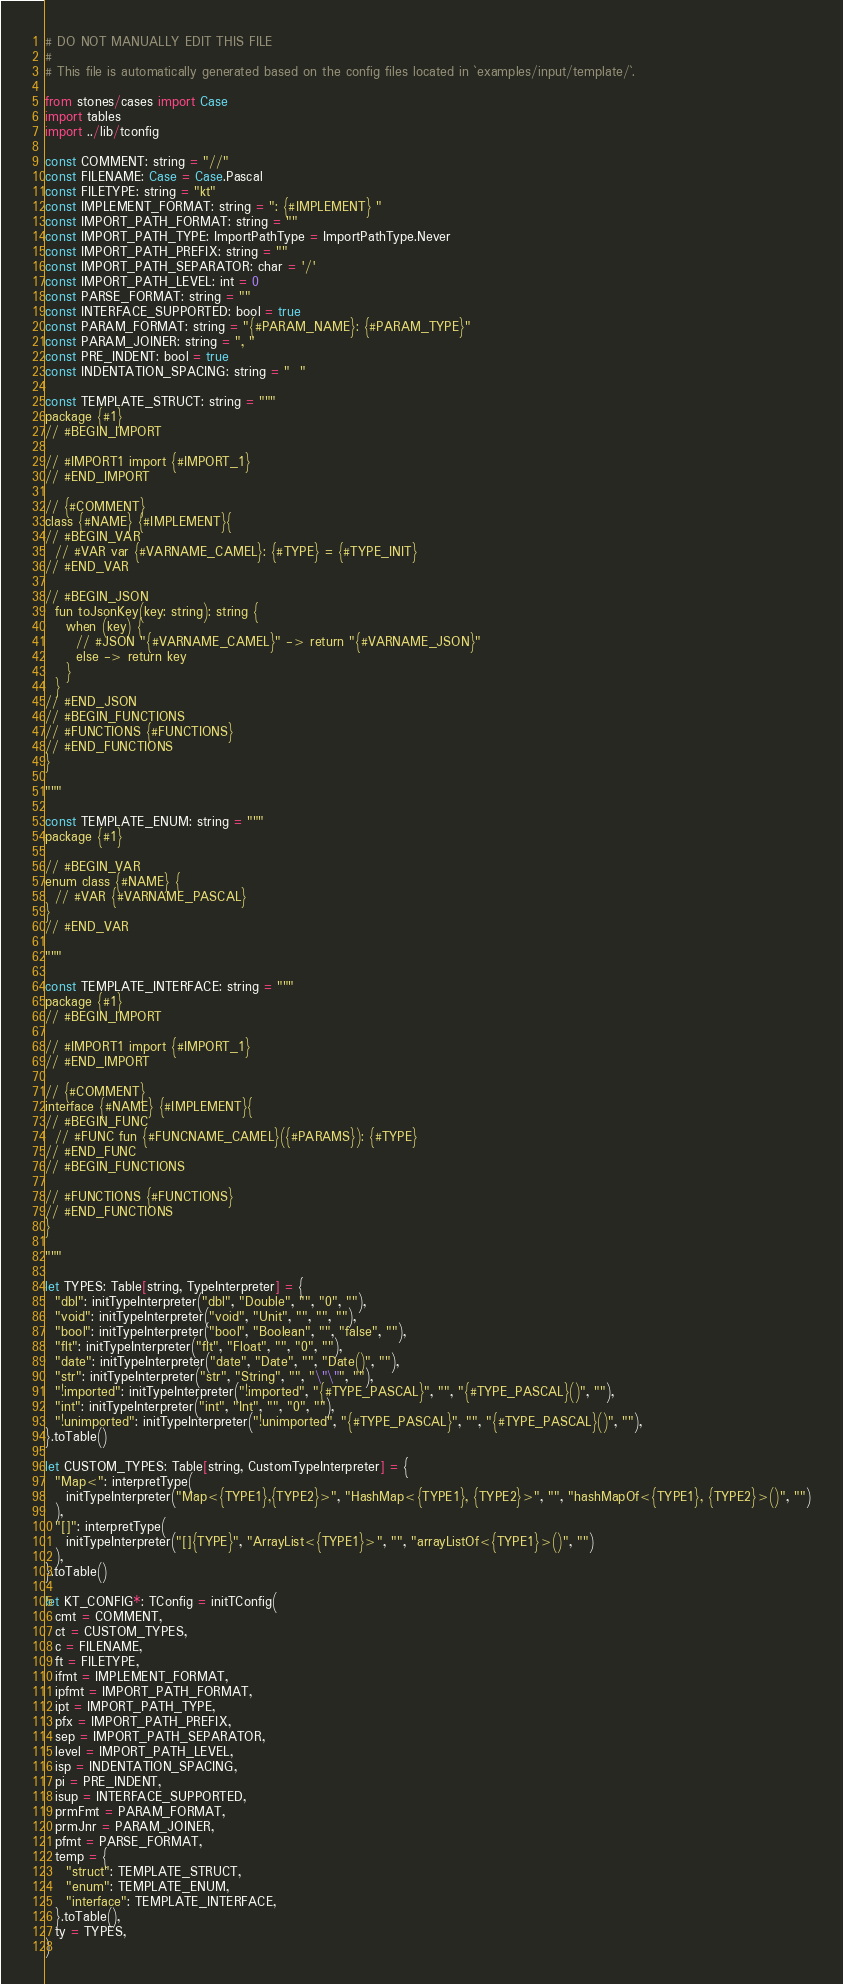<code> <loc_0><loc_0><loc_500><loc_500><_Nim_># DO NOT MANUALLY EDIT THIS FILE
#
# This file is automatically generated based on the config files located in `examples/input/template/`.

from stones/cases import Case
import tables
import ../lib/tconfig

const COMMENT: string = "//"
const FILENAME: Case = Case.Pascal
const FILETYPE: string = "kt"
const IMPLEMENT_FORMAT: string = ": {#IMPLEMENT} "
const IMPORT_PATH_FORMAT: string = ""
const IMPORT_PATH_TYPE: ImportPathType = ImportPathType.Never
const IMPORT_PATH_PREFIX: string = ""
const IMPORT_PATH_SEPARATOR: char = '/'
const IMPORT_PATH_LEVEL: int = 0
const PARSE_FORMAT: string = ""
const INTERFACE_SUPPORTED: bool = true
const PARAM_FORMAT: string = "{#PARAM_NAME}: {#PARAM_TYPE}"
const PARAM_JOINER: string = ", "
const PRE_INDENT: bool = true
const INDENTATION_SPACING: string = "  "

const TEMPLATE_STRUCT: string = """
package {#1}
// #BEGIN_IMPORT

// #IMPORT1 import {#IMPORT_1}
// #END_IMPORT

// {#COMMENT}
class {#NAME} {#IMPLEMENT}{
// #BEGIN_VAR
  // #VAR var {#VARNAME_CAMEL}: {#TYPE} = {#TYPE_INIT}
// #END_VAR

// #BEGIN_JSON
  fun toJsonKey(key: string): string {
    when (key) {
      // #JSON "{#VARNAME_CAMEL}" -> return "{#VARNAME_JSON}"
      else -> return key
    }
  }
// #END_JSON
// #BEGIN_FUNCTIONS
// #FUNCTIONS {#FUNCTIONS}
// #END_FUNCTIONS
}

"""

const TEMPLATE_ENUM: string = """
package {#1}

// #BEGIN_VAR
enum class {#NAME} {
  // #VAR {#VARNAME_PASCAL}
}
// #END_VAR

"""

const TEMPLATE_INTERFACE: string = """
package {#1}
// #BEGIN_IMPORT

// #IMPORT1 import {#IMPORT_1}
// #END_IMPORT

// {#COMMENT}
interface {#NAME} {#IMPLEMENT}{
// #BEGIN_FUNC
  // #FUNC fun {#FUNCNAME_CAMEL}({#PARAMS}): {#TYPE}
// #END_FUNC
// #BEGIN_FUNCTIONS

// #FUNCTIONS {#FUNCTIONS}
// #END_FUNCTIONS
}

"""

let TYPES: Table[string, TypeInterpreter] = {
  "dbl": initTypeInterpreter("dbl", "Double", "", "0", ""),
  "void": initTypeInterpreter("void", "Unit", "", "", ""),
  "bool": initTypeInterpreter("bool", "Boolean", "", "false", ""),
  "flt": initTypeInterpreter("flt", "Float", "", "0", ""),
  "date": initTypeInterpreter("date", "Date", "", "Date()", ""),
  "str": initTypeInterpreter("str", "String", "", "\"\"", ""),
  "!imported": initTypeInterpreter("!imported", "{#TYPE_PASCAL}", "", "{#TYPE_PASCAL}()", ""),
  "int": initTypeInterpreter("int", "Int", "", "0", ""),
  "!unimported": initTypeInterpreter("!unimported", "{#TYPE_PASCAL}", "", "{#TYPE_PASCAL}()", ""),
}.toTable()

let CUSTOM_TYPES: Table[string, CustomTypeInterpreter] = {
  "Map<": interpretType(
    initTypeInterpreter("Map<{TYPE1},{TYPE2}>", "HashMap<{TYPE1}, {TYPE2}>", "", "hashMapOf<{TYPE1}, {TYPE2}>()", "")
  ),
  "[]": interpretType(
    initTypeInterpreter("[]{TYPE}", "ArrayList<{TYPE1}>", "", "arrayListOf<{TYPE1}>()", "")
  ),
}.toTable()

let KT_CONFIG*: TConfig = initTConfig(
  cmt = COMMENT,
  ct = CUSTOM_TYPES,
  c = FILENAME,
  ft = FILETYPE,
  ifmt = IMPLEMENT_FORMAT,
  ipfmt = IMPORT_PATH_FORMAT,
  ipt = IMPORT_PATH_TYPE,
  pfx = IMPORT_PATH_PREFIX,
  sep = IMPORT_PATH_SEPARATOR,
  level = IMPORT_PATH_LEVEL,
  isp = INDENTATION_SPACING,
  pi = PRE_INDENT,
  isup = INTERFACE_SUPPORTED,
  prmFmt = PARAM_FORMAT,
  prmJnr = PARAM_JOINER,
  pfmt = PARSE_FORMAT,
  temp = {
    "struct": TEMPLATE_STRUCT,
    "enum": TEMPLATE_ENUM,
    "interface": TEMPLATE_INTERFACE,
  }.toTable(),
  ty = TYPES,
)
</code> 